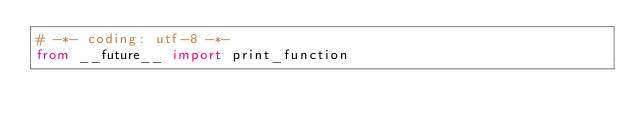<code> <loc_0><loc_0><loc_500><loc_500><_Python_># -*- coding: utf-8 -*-
from __future__ import print_function

</code> 